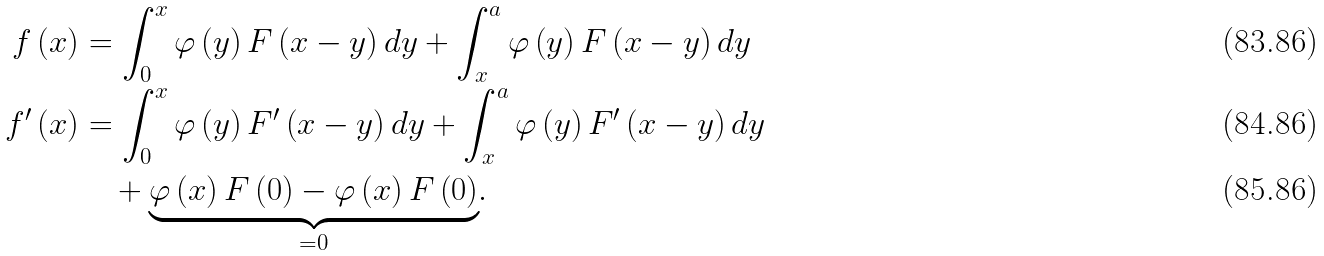<formula> <loc_0><loc_0><loc_500><loc_500>f \left ( x \right ) & = \int _ { 0 } ^ { x } \varphi \left ( y \right ) F \left ( x - y \right ) d y + \int _ { x } ^ { a } \varphi \left ( y \right ) F \left ( x - y \right ) d y \\ f ^ { \prime } \left ( x \right ) & = \int _ { 0 } ^ { x } \varphi \left ( y \right ) F ^ { \prime } \left ( x - y \right ) d y + \int _ { x } ^ { a } \varphi \left ( y \right ) F ^ { \prime } \left ( x - y \right ) d y \\ & \quad + \underset { = 0 } { \underbrace { \varphi \left ( x \right ) F \left ( 0 \right ) - \varphi \left ( x \right ) F \left ( 0 \right ) } } .</formula> 